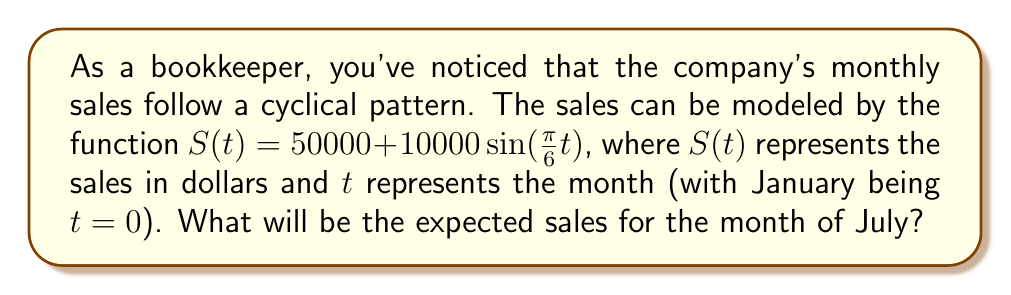Can you solve this math problem? Let's approach this step-by-step:

1) First, we need to determine which month July represents in our model. Since January is $t=0$, July would be the 7th month, so $t=6$.

2) Now, we can plug $t=6$ into our function:

   $S(6) = 50000 + 10000\sin(\frac{\pi}{6} \cdot 6)$

3) Simplify the argument of the sine function:
   
   $S(6) = 50000 + 10000\sin(\pi)$

4) Recall that $\sin(\pi) = 0$, so:

   $S(6) = 50000 + 10000 \cdot 0 = 50000$

5) Therefore, the expected sales for July (the 7th month) would be $50,000.

This makes sense in the context of the model:
- $50000 is the average sales amount
- The sine function causes the sales to oscillate by up to $10000 above or below this average
- In July ($t=6$), we're at a point where the sine function equals zero, so we're exactly at the average sales amount
Answer: $50000 